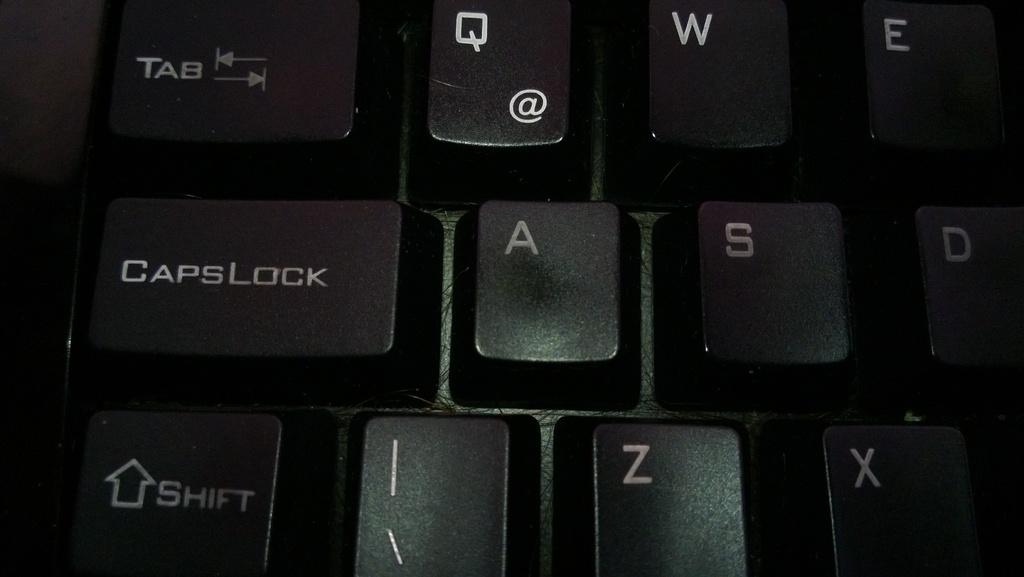What does the button in the bottom left say?
Your answer should be compact. Shift. What does the center button?
Your response must be concise. A. 